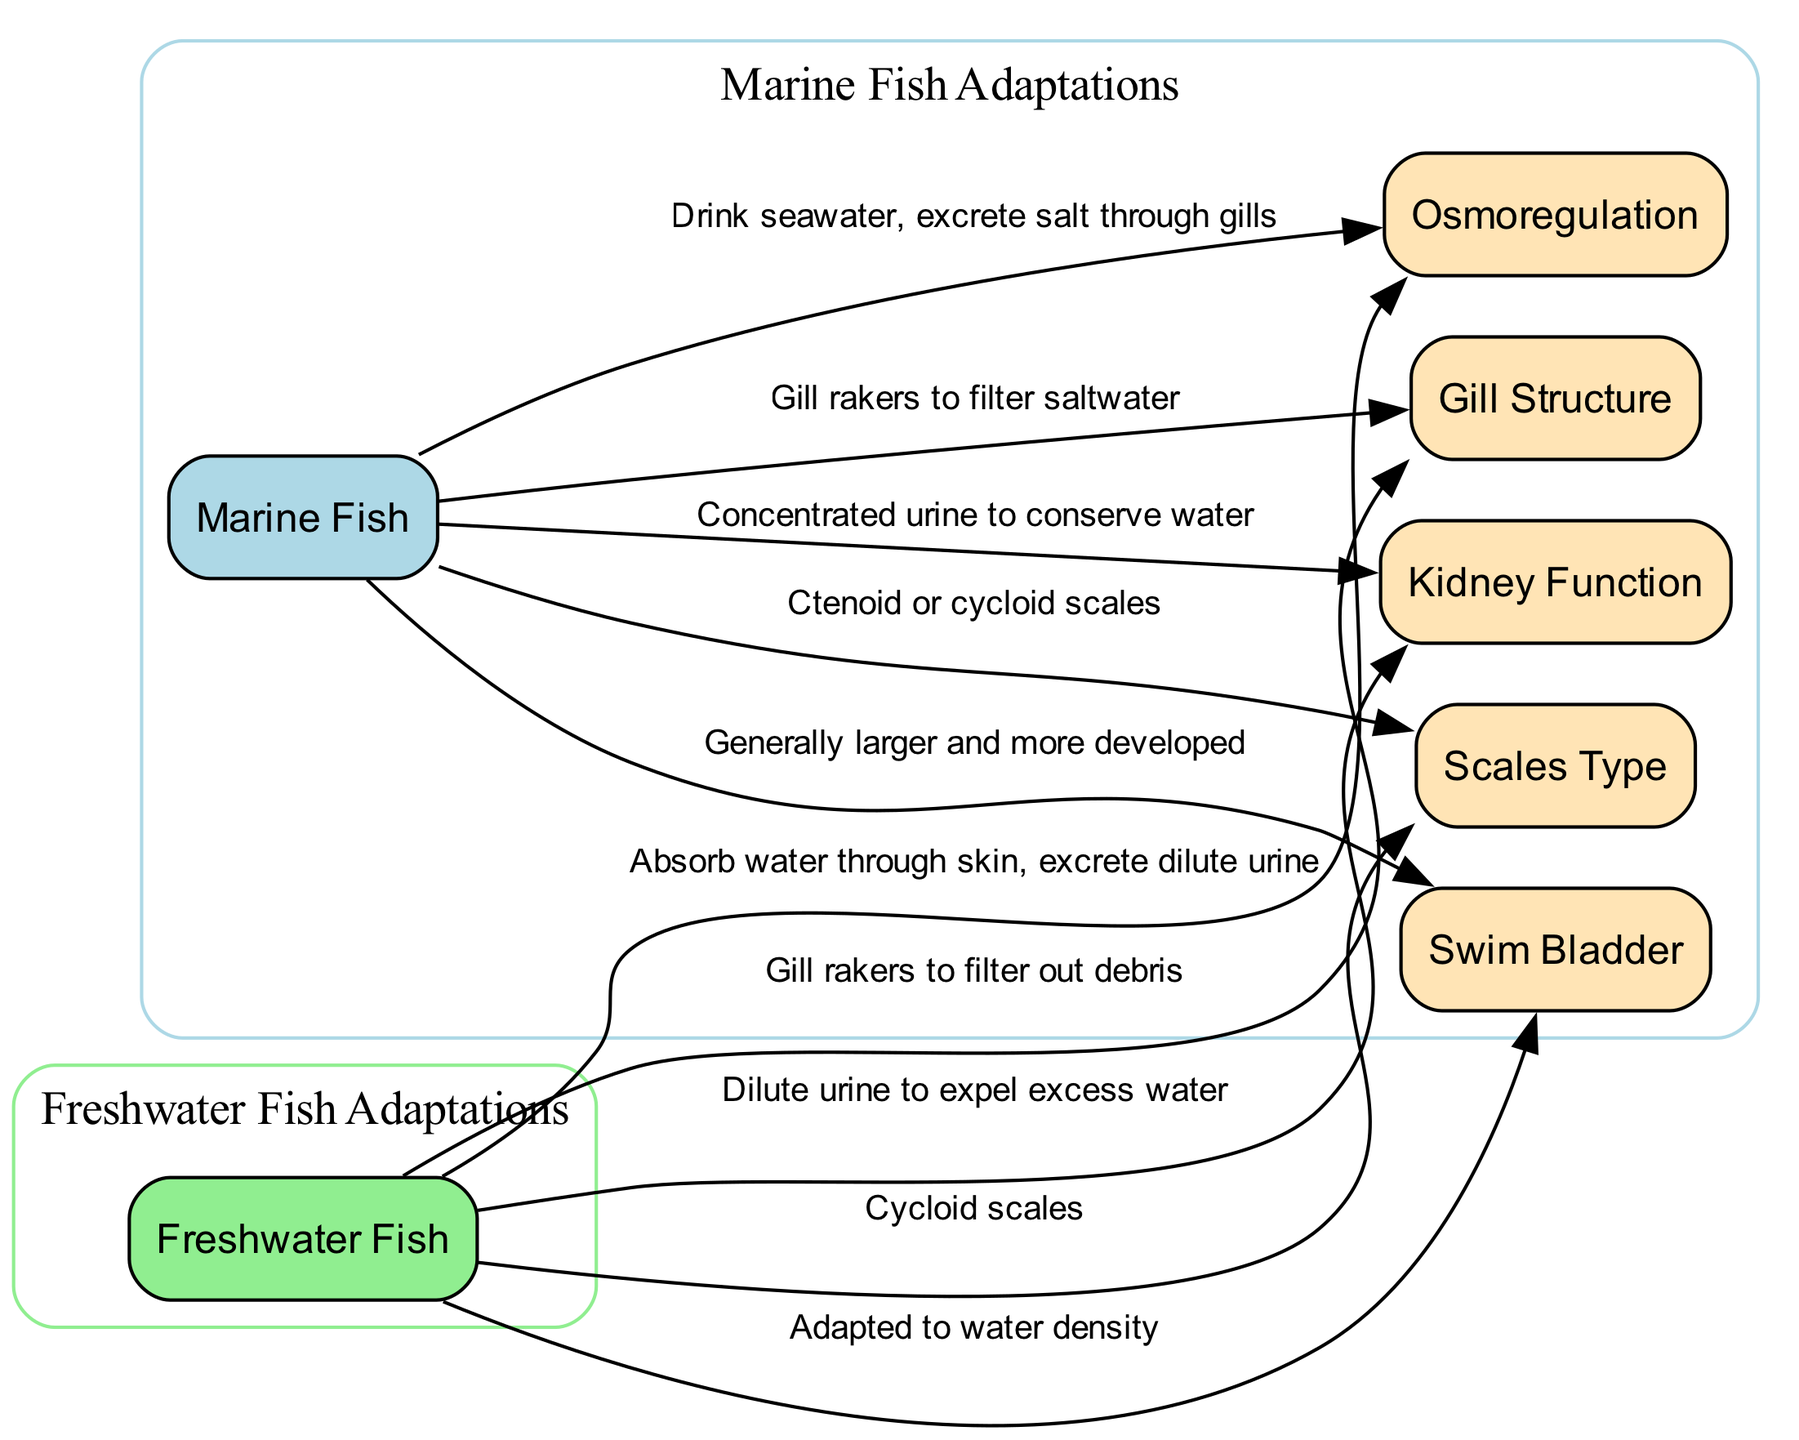What type of fish live in saltwater environments? The node labeled "Marine Fish" clearly indicates that these fish species live in saltwater environments.
Answer: Marine Fish What is the primary process for maintaining water and salt balance in freshwater fish? The node connected to "Freshwater Fish" labeled "Osmoregulation" describes that these fish absorb water through their skin, indicating the process required for maintaining balance in their freshwater habitat.
Answer: Osmoregulation How do marine fish excrete excess salt? The edge connecting "Marine Fish" to "Osmoregulation" states that they drink seawater and excrete salt through their gills, providing a direct answer to how they manage salt intake.
Answer: Through gills What type of scales do freshwater fish have? Referring to the node connected to "Freshwater Fish," it describes that they have cycloid scales, detailing the protective structure of their bodies.
Answer: Cycloid scales Which organ do marine fish use to control buoyancy? The node connected to "Marine Fish" provides information about the swim bladder as being generally larger and more developed in these species for buoyancy control.
Answer: Swim Bladder Explain how the kidney function varies between marine and freshwater fish. The diagram illustrates that marine fish have concentrated urine to conserve water, while freshwater fish excrete dilute urine to expel excess water, indicating the difference in kidney function due to environmental adaptations. This requires understanding the relationship between the respective fish types and their water management strategies.
Answer: Concentrated and dilute urine What anatomical feature helps freshwater fish filter out debris from the water? The edge indicates that freshwater fish possess gill rakers which are specifically noted for filtering out debris, highlighting an adaptation for their environment.
Answer: Gill rakers What is the adaptation of the swim bladder in freshwater fish? The swim bladder of freshwater fish is mentioned as adapted to water density. This indicates how their buoyancy control method differs from that of marine fish due to different environmental conditions.
Answer: Adapted to water density What type of scales do marine fish typically have? The node associated with marine fish describes that they typically have ctenoid or cycloid scales, outlining the protective features of their bodies.
Answer: Ctenoid or cycloid scales 